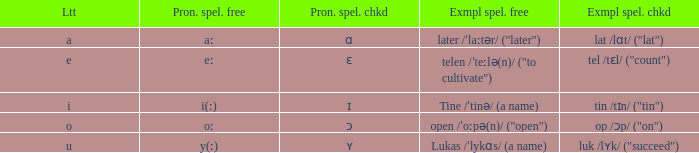What is Pronunciation Spelled Free, when Pronunciation Spelled Checked is "ɑ"? Aː. 